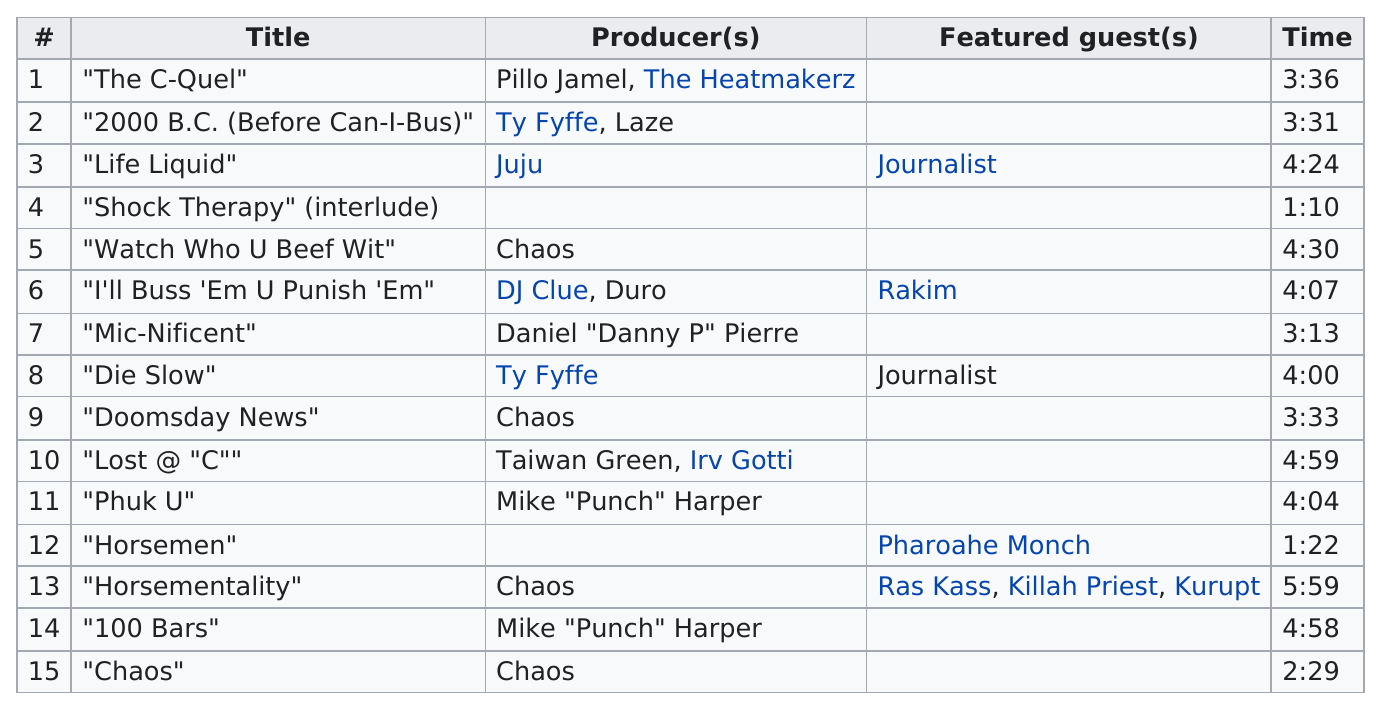Mention a couple of crucial points in this snapshot. What is the longest track in terms of time? "Horsementality". The duration of 'die slow' is approximately 4 hours. There are 7 songs that are shorter than 4 minutes in length. The songs 'Shock Therapy' (interlude) and 'Horsemen' do not have a producer listed. There are a number of songs that are at most 3 minutes long, specifically those between 3 and 3 inclusive. 